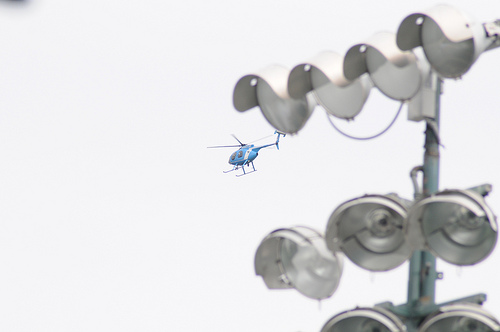<image>
Is there a helicoptor above the light? Yes. The helicoptor is positioned above the light in the vertical space, higher up in the scene. 